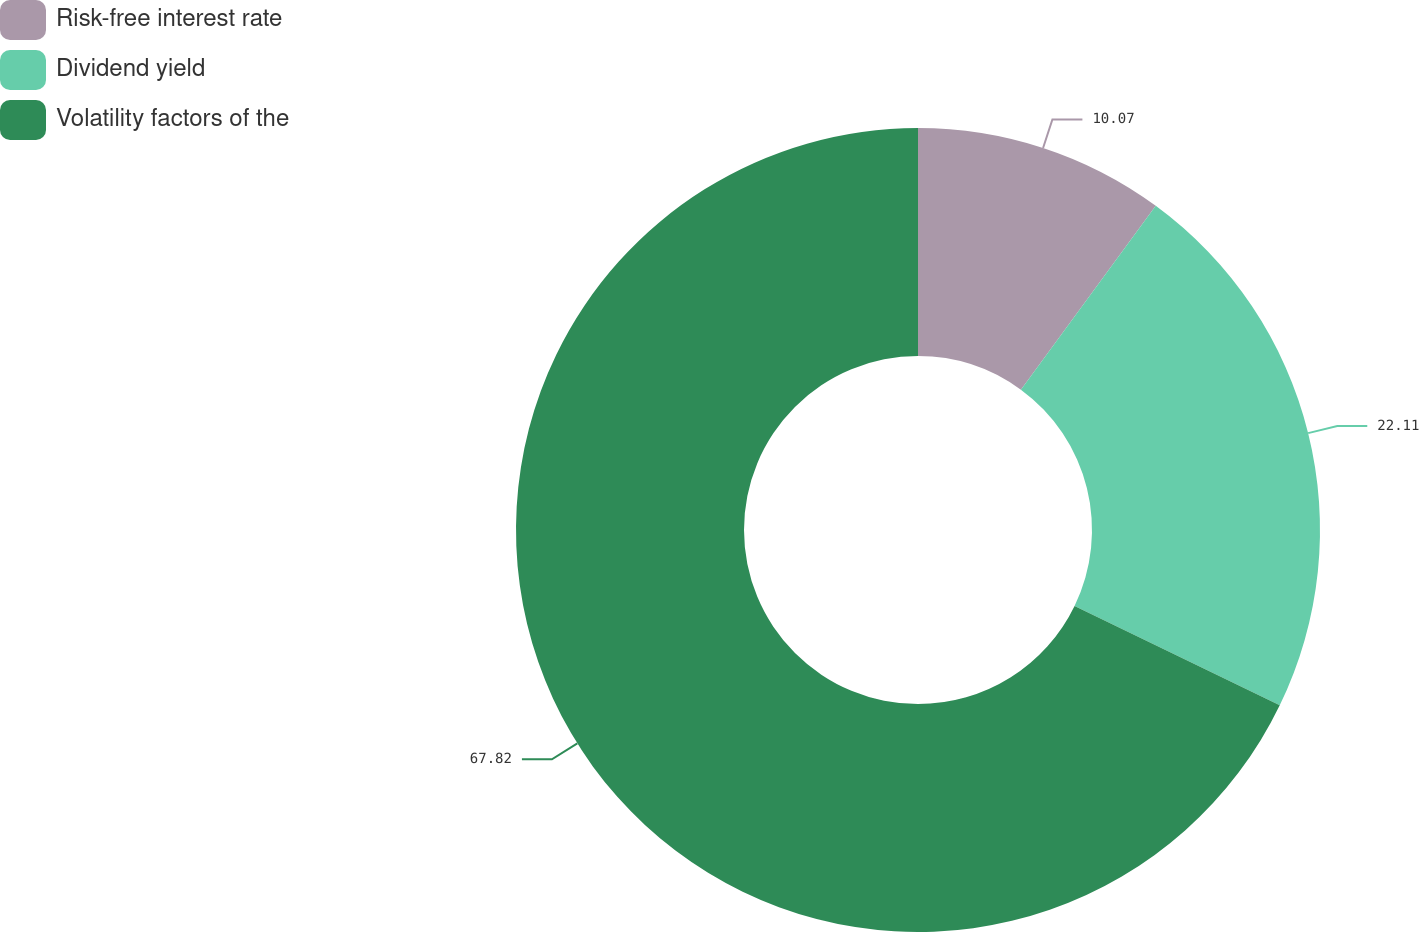<chart> <loc_0><loc_0><loc_500><loc_500><pie_chart><fcel>Risk-free interest rate<fcel>Dividend yield<fcel>Volatility factors of the<nl><fcel>10.07%<fcel>22.11%<fcel>67.81%<nl></chart> 